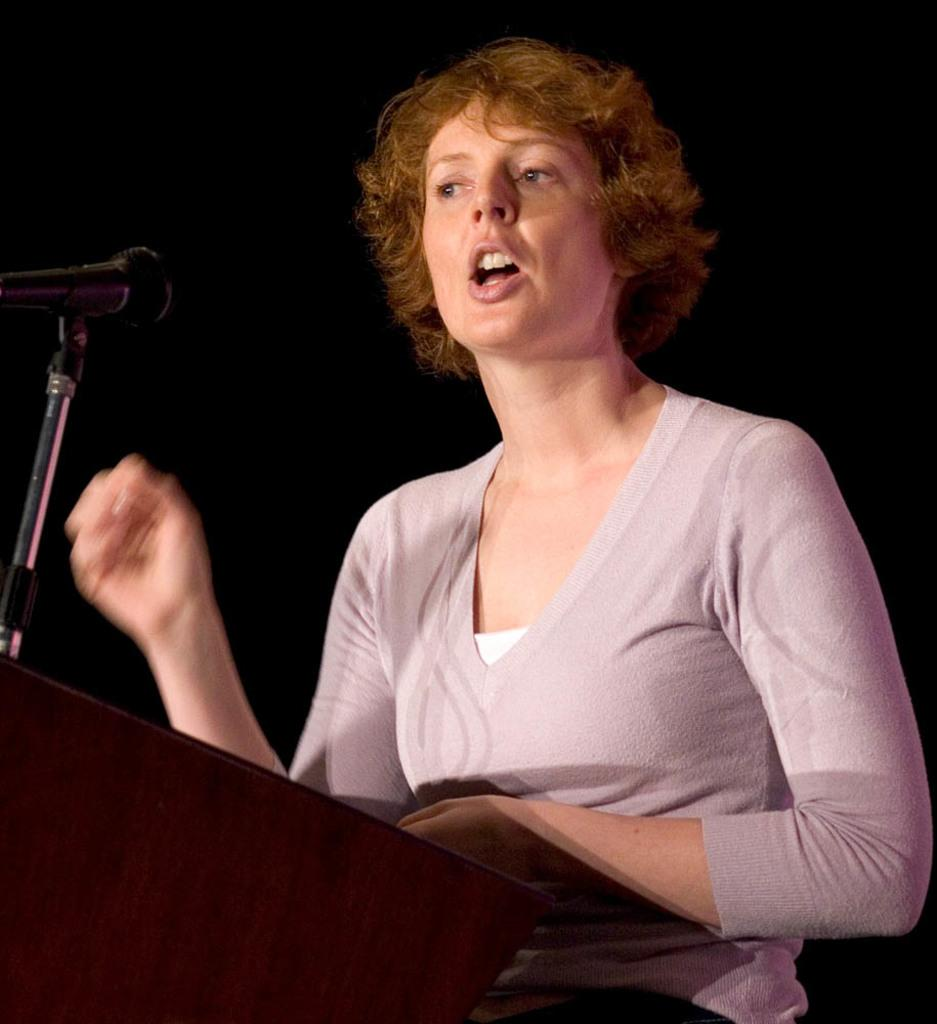What is the main subject of the image? There is a person in the image. What is the person standing in front of? The person is standing in front of a dais. What object is present on top of the dais? There is a microphone on top of the dais. What type of oatmeal is being served on the dais in the image? There is no oatmeal present in the image; it features a person standing in front of a dais with a microphone on top. What kind of trouble is the person facing in the image? There is no indication of trouble in the image; it simply shows a person standing in front of a dais with a microphone on top. 